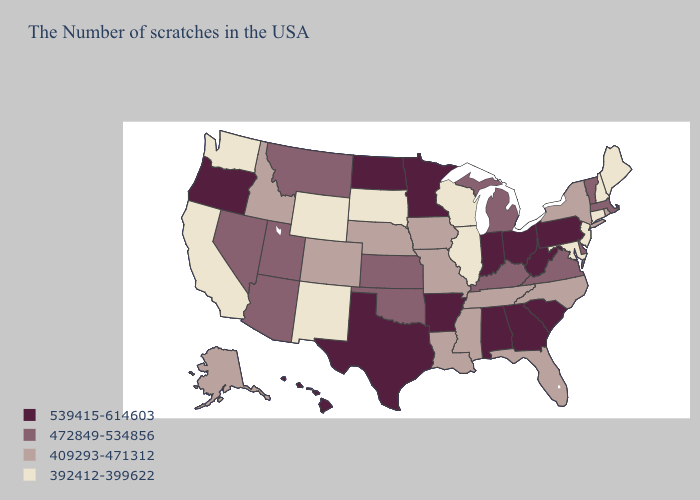Name the states that have a value in the range 539415-614603?
Give a very brief answer. Pennsylvania, South Carolina, West Virginia, Ohio, Georgia, Indiana, Alabama, Arkansas, Minnesota, Texas, North Dakota, Oregon, Hawaii. What is the lowest value in the Northeast?
Keep it brief. 392412-399622. Name the states that have a value in the range 539415-614603?
Concise answer only. Pennsylvania, South Carolina, West Virginia, Ohio, Georgia, Indiana, Alabama, Arkansas, Minnesota, Texas, North Dakota, Oregon, Hawaii. Which states have the lowest value in the USA?
Quick response, please. Maine, New Hampshire, Connecticut, New Jersey, Maryland, Wisconsin, Illinois, South Dakota, Wyoming, New Mexico, California, Washington. What is the value of Virginia?
Write a very short answer. 472849-534856. Name the states that have a value in the range 472849-534856?
Short answer required. Massachusetts, Vermont, Delaware, Virginia, Michigan, Kentucky, Kansas, Oklahoma, Utah, Montana, Arizona, Nevada. What is the lowest value in the South?
Quick response, please. 392412-399622. Name the states that have a value in the range 472849-534856?
Concise answer only. Massachusetts, Vermont, Delaware, Virginia, Michigan, Kentucky, Kansas, Oklahoma, Utah, Montana, Arizona, Nevada. Which states have the lowest value in the USA?
Short answer required. Maine, New Hampshire, Connecticut, New Jersey, Maryland, Wisconsin, Illinois, South Dakota, Wyoming, New Mexico, California, Washington. How many symbols are there in the legend?
Answer briefly. 4. Among the states that border Kentucky , which have the lowest value?
Concise answer only. Illinois. Name the states that have a value in the range 472849-534856?
Give a very brief answer. Massachusetts, Vermont, Delaware, Virginia, Michigan, Kentucky, Kansas, Oklahoma, Utah, Montana, Arizona, Nevada. What is the lowest value in the USA?
Keep it brief. 392412-399622. Does Texas have the highest value in the USA?
Keep it brief. Yes. Name the states that have a value in the range 392412-399622?
Be succinct. Maine, New Hampshire, Connecticut, New Jersey, Maryland, Wisconsin, Illinois, South Dakota, Wyoming, New Mexico, California, Washington. 